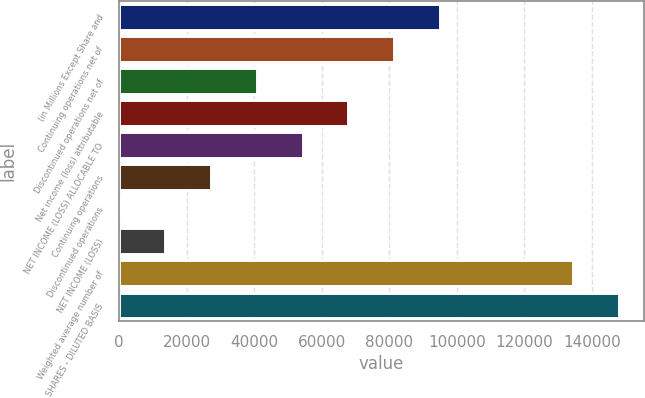<chart> <loc_0><loc_0><loc_500><loc_500><bar_chart><fcel>(in Millions Except Share and<fcel>Continuing operations net of<fcel>Discontinued operations net of<fcel>Net income (loss) attributable<fcel>NET INCOME (LOSS) ALLOCABLE TO<fcel>Continuing operations<fcel>Discontinued operations<fcel>NET INCOME (LOSS)<fcel>Weighted average number of<fcel>SHARES - DILUTED BASIS<nl><fcel>95115.6<fcel>81527.8<fcel>40764.4<fcel>67940<fcel>54352.2<fcel>27176.6<fcel>1.06<fcel>13588.9<fcel>134406<fcel>147994<nl></chart> 